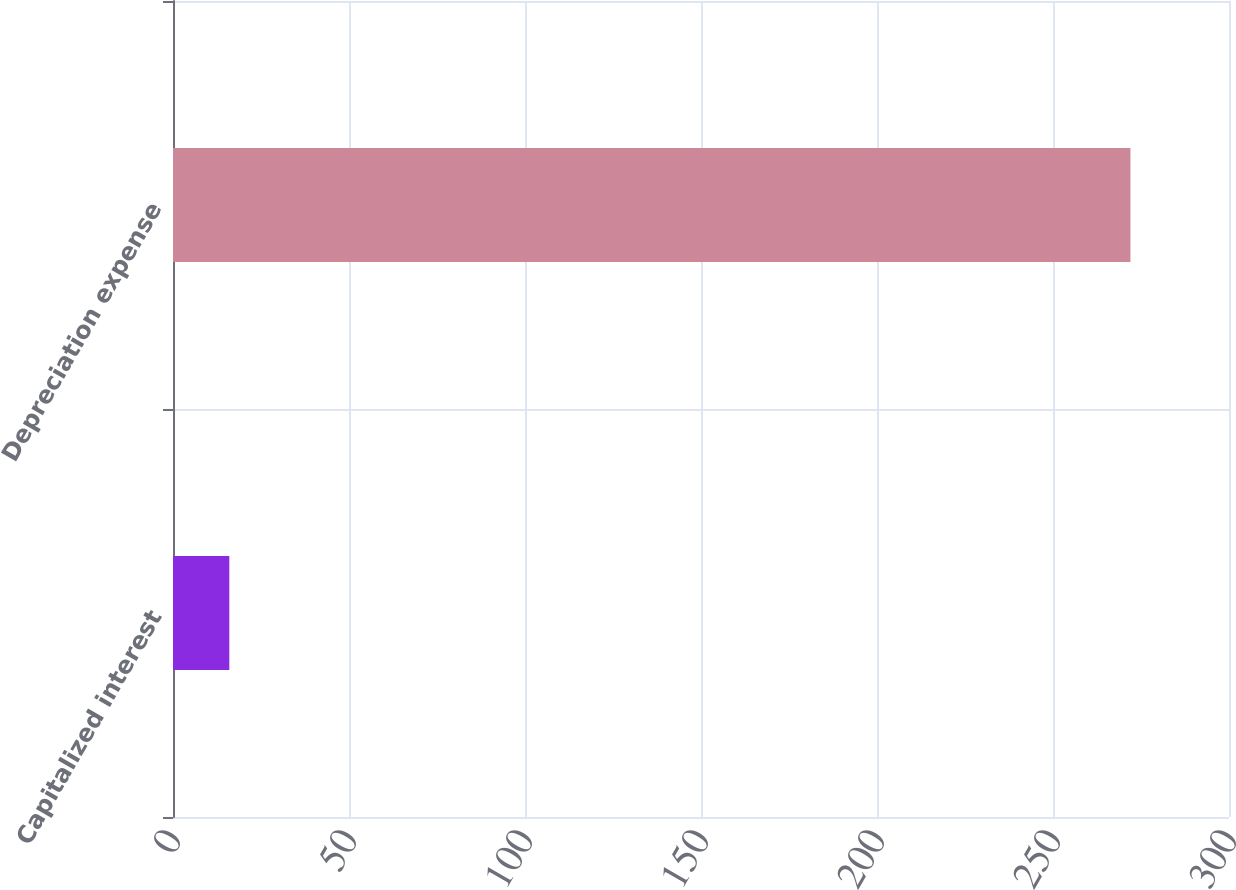<chart> <loc_0><loc_0><loc_500><loc_500><bar_chart><fcel>Capitalized interest<fcel>Depreciation expense<nl><fcel>16<fcel>272<nl></chart> 